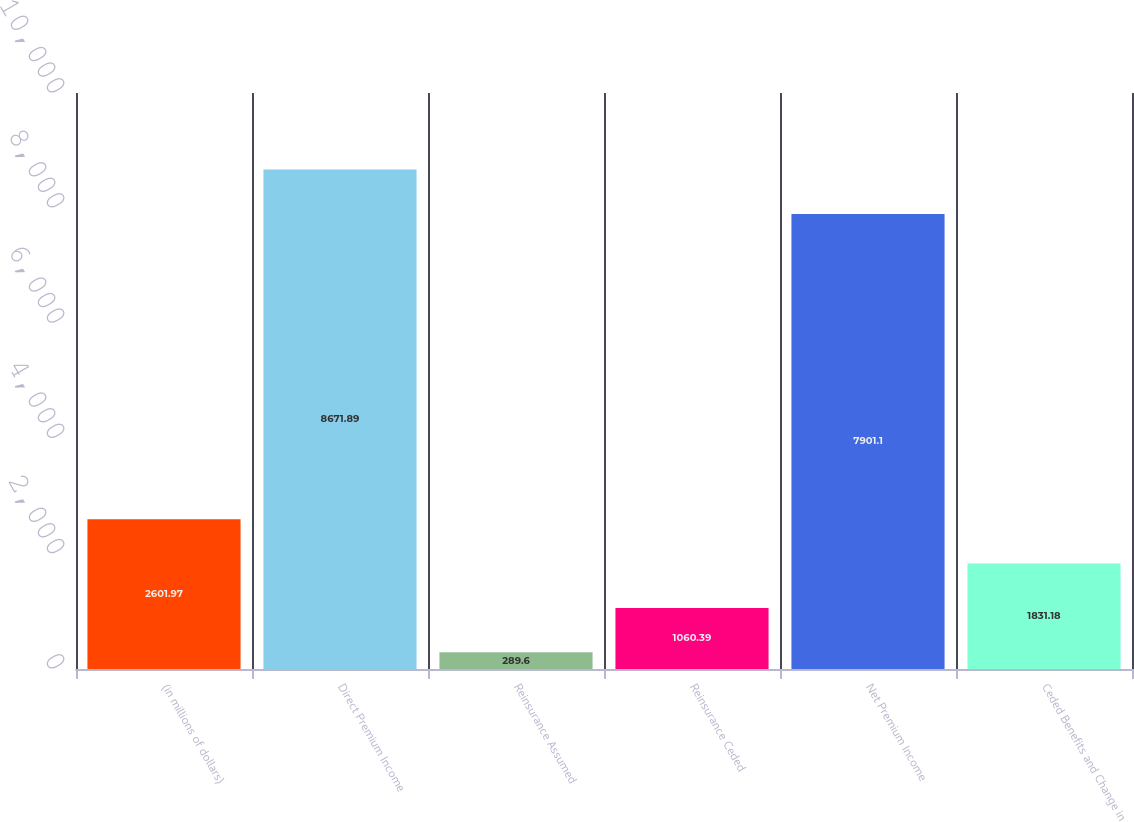Convert chart. <chart><loc_0><loc_0><loc_500><loc_500><bar_chart><fcel>(in millions of dollars)<fcel>Direct Premium Income<fcel>Reinsurance Assumed<fcel>Reinsurance Ceded<fcel>Net Premium Income<fcel>Ceded Benefits and Change in<nl><fcel>2601.97<fcel>8671.89<fcel>289.6<fcel>1060.39<fcel>7901.1<fcel>1831.18<nl></chart> 